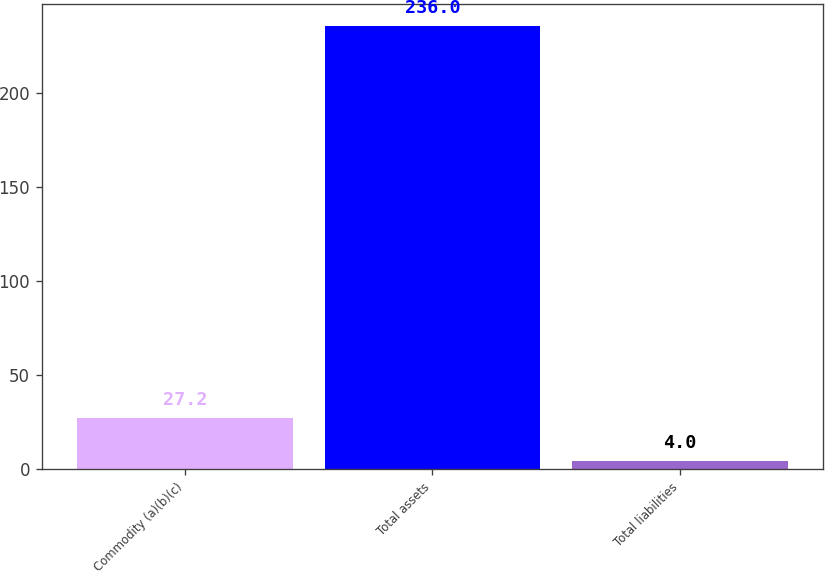Convert chart to OTSL. <chart><loc_0><loc_0><loc_500><loc_500><bar_chart><fcel>Commodity (a)(b)(c)<fcel>Total assets<fcel>Total liabilities<nl><fcel>27.2<fcel>236<fcel>4<nl></chart> 